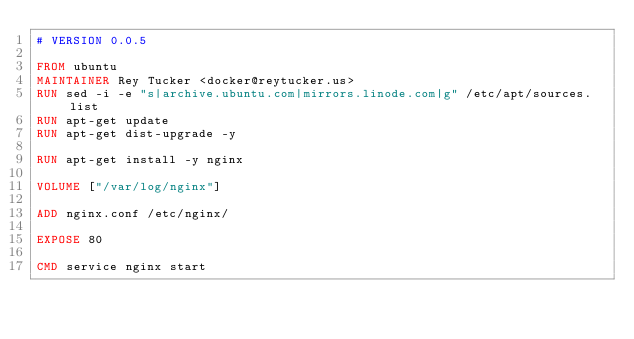Convert code to text. <code><loc_0><loc_0><loc_500><loc_500><_Dockerfile_># VERSION 0.0.5

FROM ubuntu
MAINTAINER Rey Tucker <docker@reytucker.us>
RUN sed -i -e "s|archive.ubuntu.com|mirrors.linode.com|g" /etc/apt/sources.list
RUN apt-get update
RUN apt-get dist-upgrade -y

RUN apt-get install -y nginx

VOLUME ["/var/log/nginx"]

ADD nginx.conf /etc/nginx/

EXPOSE 80

CMD service nginx start
</code> 